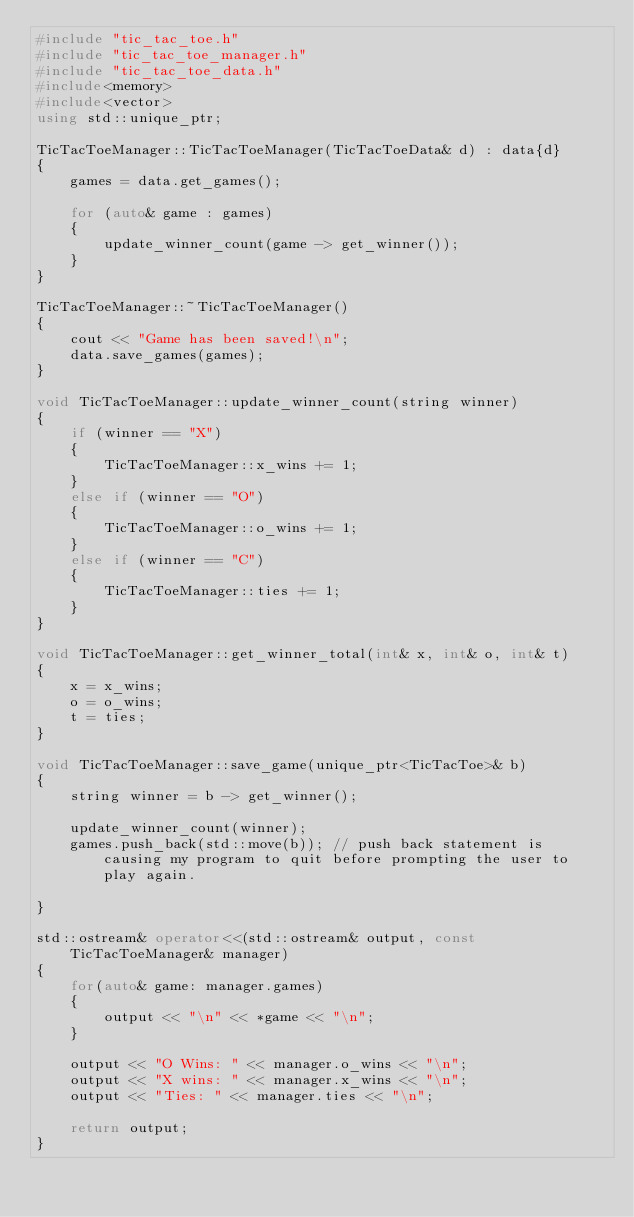<code> <loc_0><loc_0><loc_500><loc_500><_C++_>#include "tic_tac_toe.h"
#include "tic_tac_toe_manager.h"
#include "tic_tac_toe_data.h"
#include<memory>
#include<vector>
using std::unique_ptr;

TicTacToeManager::TicTacToeManager(TicTacToeData& d) : data{d}
{
    games = data.get_games();

    for (auto& game : games) 
    {
        update_winner_count(game -> get_winner());
    }
}

TicTacToeManager::~TicTacToeManager() 
{
    cout << "Game has been saved!\n";
    data.save_games(games);
}

void TicTacToeManager::update_winner_count(string winner) 
{
    if (winner == "X") 
    {
        TicTacToeManager::x_wins += 1;
    }
    else if (winner == "O") 
    {
        TicTacToeManager::o_wins += 1;
    }
    else if (winner == "C") 
    {
        TicTacToeManager::ties += 1;
    }
}

void TicTacToeManager::get_winner_total(int& x, int& o, int& t) 
{
    x = x_wins;
    o = o_wins;
    t = ties;
}

void TicTacToeManager::save_game(unique_ptr<TicTacToe>& b)
{
    string winner = b -> get_winner();

    update_winner_count(winner);
    games.push_back(std::move(b)); // push back statement is causing my program to quit before prompting the user to play again.
        
}

std::ostream& operator<<(std::ostream& output, const TicTacToeManager& manager) 
{
    for(auto& game: manager.games) 
    {
        output << "\n" << *game << "\n";
    }

    output << "O Wins: " << manager.o_wins << "\n";
    output << "X wins: " << manager.x_wins << "\n";
    output << "Ties: " << manager.ties << "\n";

    return output;
}</code> 